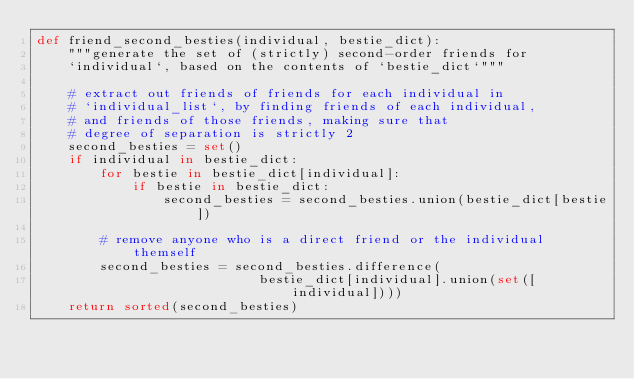<code> <loc_0><loc_0><loc_500><loc_500><_Python_>def friend_second_besties(individual, bestie_dict):
    """generate the set of (strictly) second-order friends for 
    `individual`, based on the contents of `bestie_dict`"""

    # extract out friends of friends for each individual in
    # `individual_list`, by finding friends of each individual,
    # and friends of those friends, making sure that
    # degree of separation is strictly 2
    second_besties = set()
    if individual in bestie_dict:
        for bestie in bestie_dict[individual]:
            if bestie in bestie_dict:
                second_besties = second_besties.union(bestie_dict[bestie])

        # remove anyone who is a direct friend or the individual themself
        second_besties = second_besties.difference(
                            bestie_dict[individual].union(set([individual])))
    return sorted(second_besties)
    
</code> 